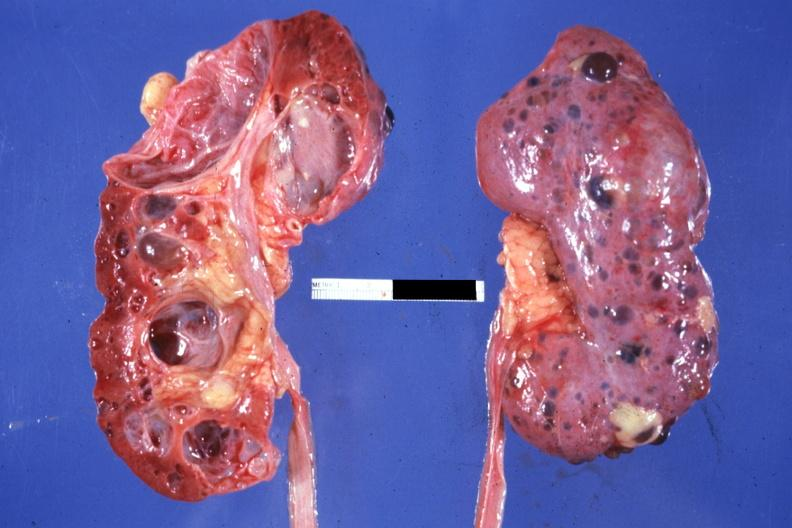what is nice photo one kidney opened?
Answer the question using a single word or phrase. Nice 